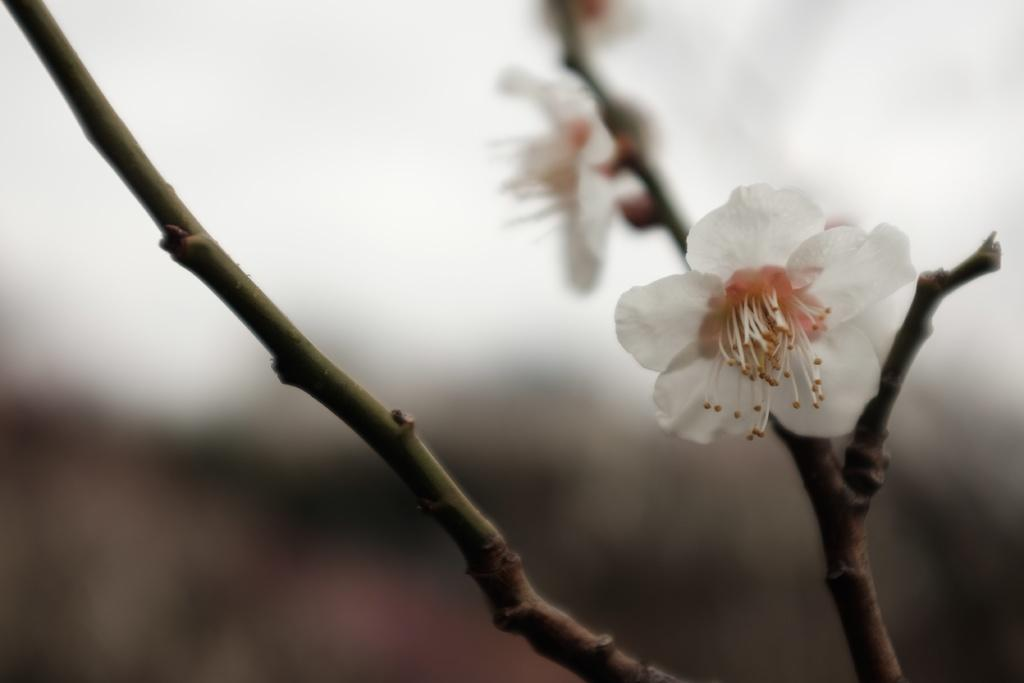What type of plants are visible in the image? There are flowers in the image. What part of the flowers can be seen in the image? There are stems in the image. Can you describe the background of the image? The background of the image is blurred. How many girls are sitting on the truck in the image? There are no girls or trucks present in the image; it features flowers and blurred background. 